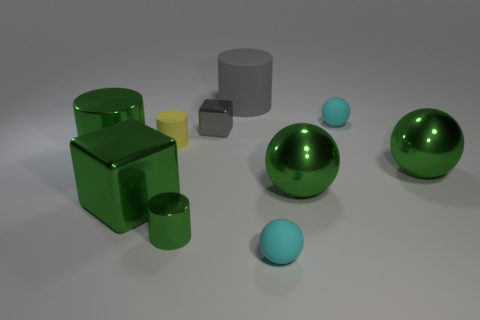Do the small gray cube and the cube in front of the small yellow rubber cylinder have the same material?
Your answer should be compact. Yes. There is a rubber cylinder left of the big gray cylinder; how big is it?
Provide a short and direct response. Small. Are there fewer large gray balls than large green metal cylinders?
Ensure brevity in your answer.  Yes. Is there a tiny metallic thing that has the same color as the tiny matte cylinder?
Keep it short and to the point. No. What shape is the matte object that is to the right of the large gray cylinder and behind the tiny gray thing?
Provide a short and direct response. Sphere. There is a gray object to the left of the large rubber cylinder that is right of the tiny green metallic cylinder; what shape is it?
Provide a short and direct response. Cube. Is the yellow matte thing the same shape as the large gray object?
Give a very brief answer. Yes. There is a tiny cube that is the same color as the large matte cylinder; what is its material?
Ensure brevity in your answer.  Metal. Does the small metallic block have the same color as the tiny metal cylinder?
Provide a succinct answer. No. What number of green spheres are left of the object to the right of the cyan ball behind the gray cube?
Keep it short and to the point. 1. 